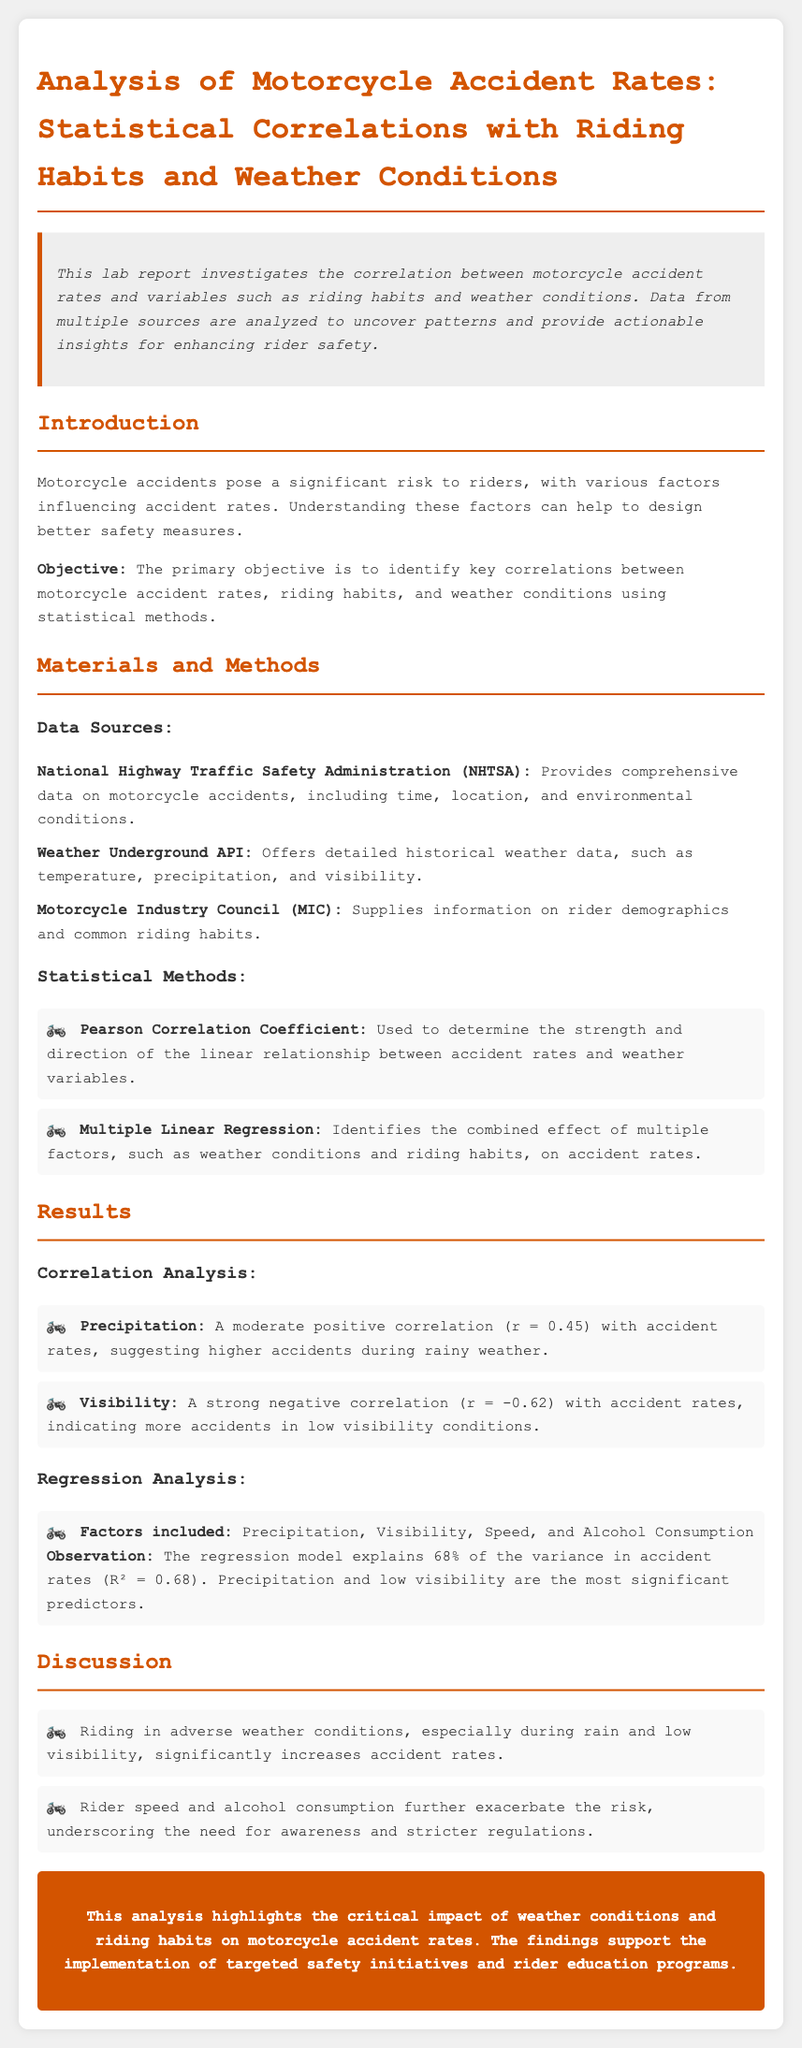What is the primary objective of the report? The primary objective is to identify key correlations between motorcycle accident rates, riding habits, and weather conditions using statistical methods.
Answer: Identify key correlations between motorcycle accident rates, riding habits, and weather conditions using statistical methods What data source provides information on rider demographics? The document lists various data sources and identifies the Motorcycle Industry Council (MIC) as the provider of information on rider demographics.
Answer: Motorcycle Industry Council (MIC) What is the Pearson Correlation Coefficient used for? The Pearson Correlation Coefficient is specifically mentioned as a method to determine the strength and direction of the linear relationship between accident rates and weather variables.
Answer: Determine the strength and direction of the linear relationship between accident rates and weather variables What correlation coefficient value indicates a moderate positive correlation with accident rates due to precipitation? The document states a specific correlation coefficient value of r equals 0.45 for precipitation.
Answer: 0.45 What is the R-squared value of the regression model analyzing the factors affecting accident rates? The regression model's ability to explain the variance in accident rates is quantified, with an R-squared value of 0.68 mentioned in the results.
Answer: 0.68 What weather condition is associated with more accidents according to the analysis? The analysis indicates that precipitation is associated with higher accident rates, which is considered a significant finding in the report.
Answer: Precipitation What two factors are highlighted as the most significant predictors in the regression analysis? The report emphasizes that precipitation and low visibility are the most significant predictors contributing to motorcycle accident rates.
Answer: Precipitation and low visibility What essential need is underscored in the discussion section regarding riding habits? The document emphasizes the need for awareness and stricter regulations, particularly related to rider speed and alcohol consumption.
Answer: Awareness and stricter regulations 